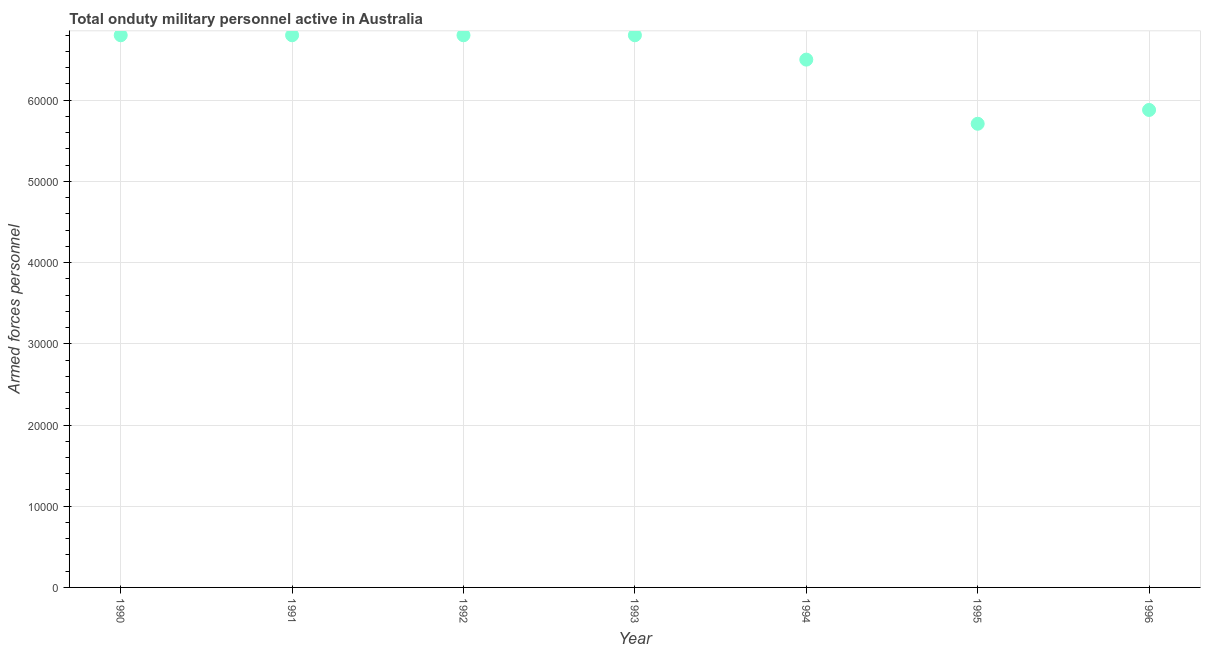What is the number of armed forces personnel in 1995?
Your response must be concise. 5.71e+04. Across all years, what is the maximum number of armed forces personnel?
Your response must be concise. 6.80e+04. Across all years, what is the minimum number of armed forces personnel?
Your answer should be compact. 5.71e+04. In which year was the number of armed forces personnel minimum?
Give a very brief answer. 1995. What is the sum of the number of armed forces personnel?
Offer a very short reply. 4.53e+05. What is the difference between the number of armed forces personnel in 1990 and 1996?
Offer a terse response. 9200. What is the average number of armed forces personnel per year?
Provide a succinct answer. 6.47e+04. What is the median number of armed forces personnel?
Provide a short and direct response. 6.80e+04. Do a majority of the years between 1992 and 1995 (inclusive) have number of armed forces personnel greater than 18000 ?
Provide a succinct answer. Yes. What is the ratio of the number of armed forces personnel in 1992 to that in 1994?
Make the answer very short. 1.05. Is the number of armed forces personnel in 1993 less than that in 1995?
Offer a terse response. No. Is the difference between the number of armed forces personnel in 1990 and 1995 greater than the difference between any two years?
Provide a succinct answer. Yes. Is the sum of the number of armed forces personnel in 1990 and 1992 greater than the maximum number of armed forces personnel across all years?
Your response must be concise. Yes. What is the difference between the highest and the lowest number of armed forces personnel?
Keep it short and to the point. 1.09e+04. In how many years, is the number of armed forces personnel greater than the average number of armed forces personnel taken over all years?
Make the answer very short. 5. Does the number of armed forces personnel monotonically increase over the years?
Your answer should be compact. No. How many dotlines are there?
Offer a terse response. 1. What is the difference between two consecutive major ticks on the Y-axis?
Give a very brief answer. 10000. Does the graph contain any zero values?
Ensure brevity in your answer.  No. What is the title of the graph?
Offer a terse response. Total onduty military personnel active in Australia. What is the label or title of the Y-axis?
Provide a short and direct response. Armed forces personnel. What is the Armed forces personnel in 1990?
Keep it short and to the point. 6.80e+04. What is the Armed forces personnel in 1991?
Your response must be concise. 6.80e+04. What is the Armed forces personnel in 1992?
Offer a very short reply. 6.80e+04. What is the Armed forces personnel in 1993?
Provide a succinct answer. 6.80e+04. What is the Armed forces personnel in 1994?
Keep it short and to the point. 6.50e+04. What is the Armed forces personnel in 1995?
Offer a very short reply. 5.71e+04. What is the Armed forces personnel in 1996?
Provide a short and direct response. 5.88e+04. What is the difference between the Armed forces personnel in 1990 and 1991?
Your answer should be compact. 0. What is the difference between the Armed forces personnel in 1990 and 1992?
Provide a short and direct response. 0. What is the difference between the Armed forces personnel in 1990 and 1994?
Your response must be concise. 3000. What is the difference between the Armed forces personnel in 1990 and 1995?
Offer a very short reply. 1.09e+04. What is the difference between the Armed forces personnel in 1990 and 1996?
Your response must be concise. 9200. What is the difference between the Armed forces personnel in 1991 and 1993?
Provide a succinct answer. 0. What is the difference between the Armed forces personnel in 1991 and 1994?
Offer a very short reply. 3000. What is the difference between the Armed forces personnel in 1991 and 1995?
Provide a succinct answer. 1.09e+04. What is the difference between the Armed forces personnel in 1991 and 1996?
Your answer should be compact. 9200. What is the difference between the Armed forces personnel in 1992 and 1994?
Your answer should be compact. 3000. What is the difference between the Armed forces personnel in 1992 and 1995?
Your answer should be very brief. 1.09e+04. What is the difference between the Armed forces personnel in 1992 and 1996?
Offer a terse response. 9200. What is the difference between the Armed forces personnel in 1993 and 1994?
Your answer should be very brief. 3000. What is the difference between the Armed forces personnel in 1993 and 1995?
Offer a very short reply. 1.09e+04. What is the difference between the Armed forces personnel in 1993 and 1996?
Ensure brevity in your answer.  9200. What is the difference between the Armed forces personnel in 1994 and 1995?
Your answer should be very brief. 7900. What is the difference between the Armed forces personnel in 1994 and 1996?
Keep it short and to the point. 6200. What is the difference between the Armed forces personnel in 1995 and 1996?
Keep it short and to the point. -1700. What is the ratio of the Armed forces personnel in 1990 to that in 1991?
Keep it short and to the point. 1. What is the ratio of the Armed forces personnel in 1990 to that in 1993?
Offer a very short reply. 1. What is the ratio of the Armed forces personnel in 1990 to that in 1994?
Provide a succinct answer. 1.05. What is the ratio of the Armed forces personnel in 1990 to that in 1995?
Your answer should be very brief. 1.19. What is the ratio of the Armed forces personnel in 1990 to that in 1996?
Your answer should be compact. 1.16. What is the ratio of the Armed forces personnel in 1991 to that in 1994?
Provide a succinct answer. 1.05. What is the ratio of the Armed forces personnel in 1991 to that in 1995?
Provide a short and direct response. 1.19. What is the ratio of the Armed forces personnel in 1991 to that in 1996?
Your response must be concise. 1.16. What is the ratio of the Armed forces personnel in 1992 to that in 1993?
Make the answer very short. 1. What is the ratio of the Armed forces personnel in 1992 to that in 1994?
Your answer should be very brief. 1.05. What is the ratio of the Armed forces personnel in 1992 to that in 1995?
Offer a terse response. 1.19. What is the ratio of the Armed forces personnel in 1992 to that in 1996?
Give a very brief answer. 1.16. What is the ratio of the Armed forces personnel in 1993 to that in 1994?
Keep it short and to the point. 1.05. What is the ratio of the Armed forces personnel in 1993 to that in 1995?
Provide a short and direct response. 1.19. What is the ratio of the Armed forces personnel in 1993 to that in 1996?
Give a very brief answer. 1.16. What is the ratio of the Armed forces personnel in 1994 to that in 1995?
Your answer should be very brief. 1.14. What is the ratio of the Armed forces personnel in 1994 to that in 1996?
Keep it short and to the point. 1.1. 